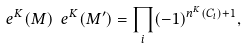<formula> <loc_0><loc_0><loc_500><loc_500>\ e ^ { K } ( M ) \ e ^ { K } ( M ^ { \prime } ) = \prod _ { i } ( - 1 ) ^ { n ^ { K } ( C _ { i } ) + 1 } ,</formula> 